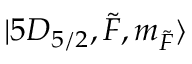<formula> <loc_0><loc_0><loc_500><loc_500>| 5 D _ { 5 / 2 } , \tilde { F } , m _ { \tilde { F } } \rangle</formula> 